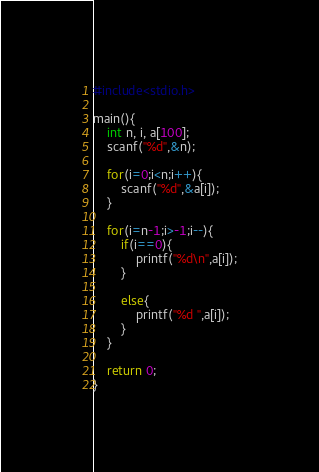<code> <loc_0><loc_0><loc_500><loc_500><_C_>#include<stdio.h>

main(){
	int n, i, a[100];
	scanf("%d",&n);
	
	for(i=0;i<n;i++){
		scanf("%d",&a[i]);
	}
	
	for(i=n-1;i>-1;i--){
		if(i==0){
			printf("%d\n",a[i]);
		}
		
		else{
			printf("%d ",a[i]);
		}
	}
	
	return 0;
}</code> 